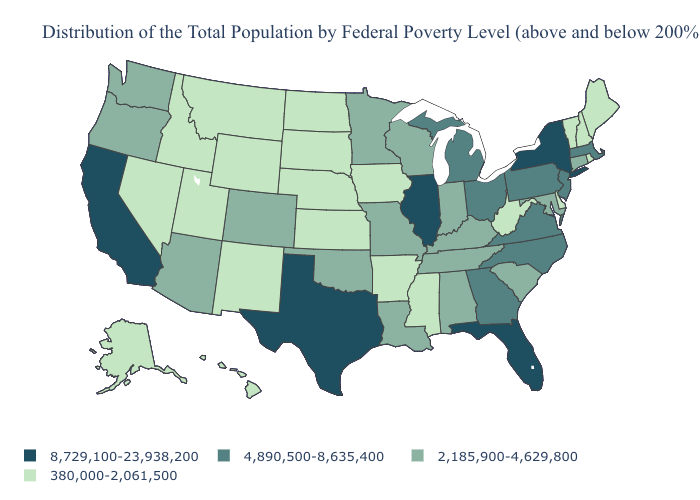Name the states that have a value in the range 4,890,500-8,635,400?
Quick response, please. Georgia, Massachusetts, Michigan, New Jersey, North Carolina, Ohio, Pennsylvania, Virginia. How many symbols are there in the legend?
Quick response, please. 4. What is the lowest value in states that border Wisconsin?
Short answer required. 380,000-2,061,500. What is the value of Idaho?
Concise answer only. 380,000-2,061,500. How many symbols are there in the legend?
Write a very short answer. 4. What is the lowest value in states that border Arkansas?
Write a very short answer. 380,000-2,061,500. What is the value of Vermont?
Concise answer only. 380,000-2,061,500. Name the states that have a value in the range 2,185,900-4,629,800?
Write a very short answer. Alabama, Arizona, Colorado, Connecticut, Indiana, Kentucky, Louisiana, Maryland, Minnesota, Missouri, Oklahoma, Oregon, South Carolina, Tennessee, Washington, Wisconsin. Does the first symbol in the legend represent the smallest category?
Concise answer only. No. What is the lowest value in states that border Missouri?
Give a very brief answer. 380,000-2,061,500. Does Illinois have the highest value in the USA?
Be succinct. Yes. Name the states that have a value in the range 8,729,100-23,938,200?
Write a very short answer. California, Florida, Illinois, New York, Texas. What is the value of Arizona?
Give a very brief answer. 2,185,900-4,629,800. What is the value of Indiana?
Answer briefly. 2,185,900-4,629,800. What is the lowest value in the South?
Quick response, please. 380,000-2,061,500. 